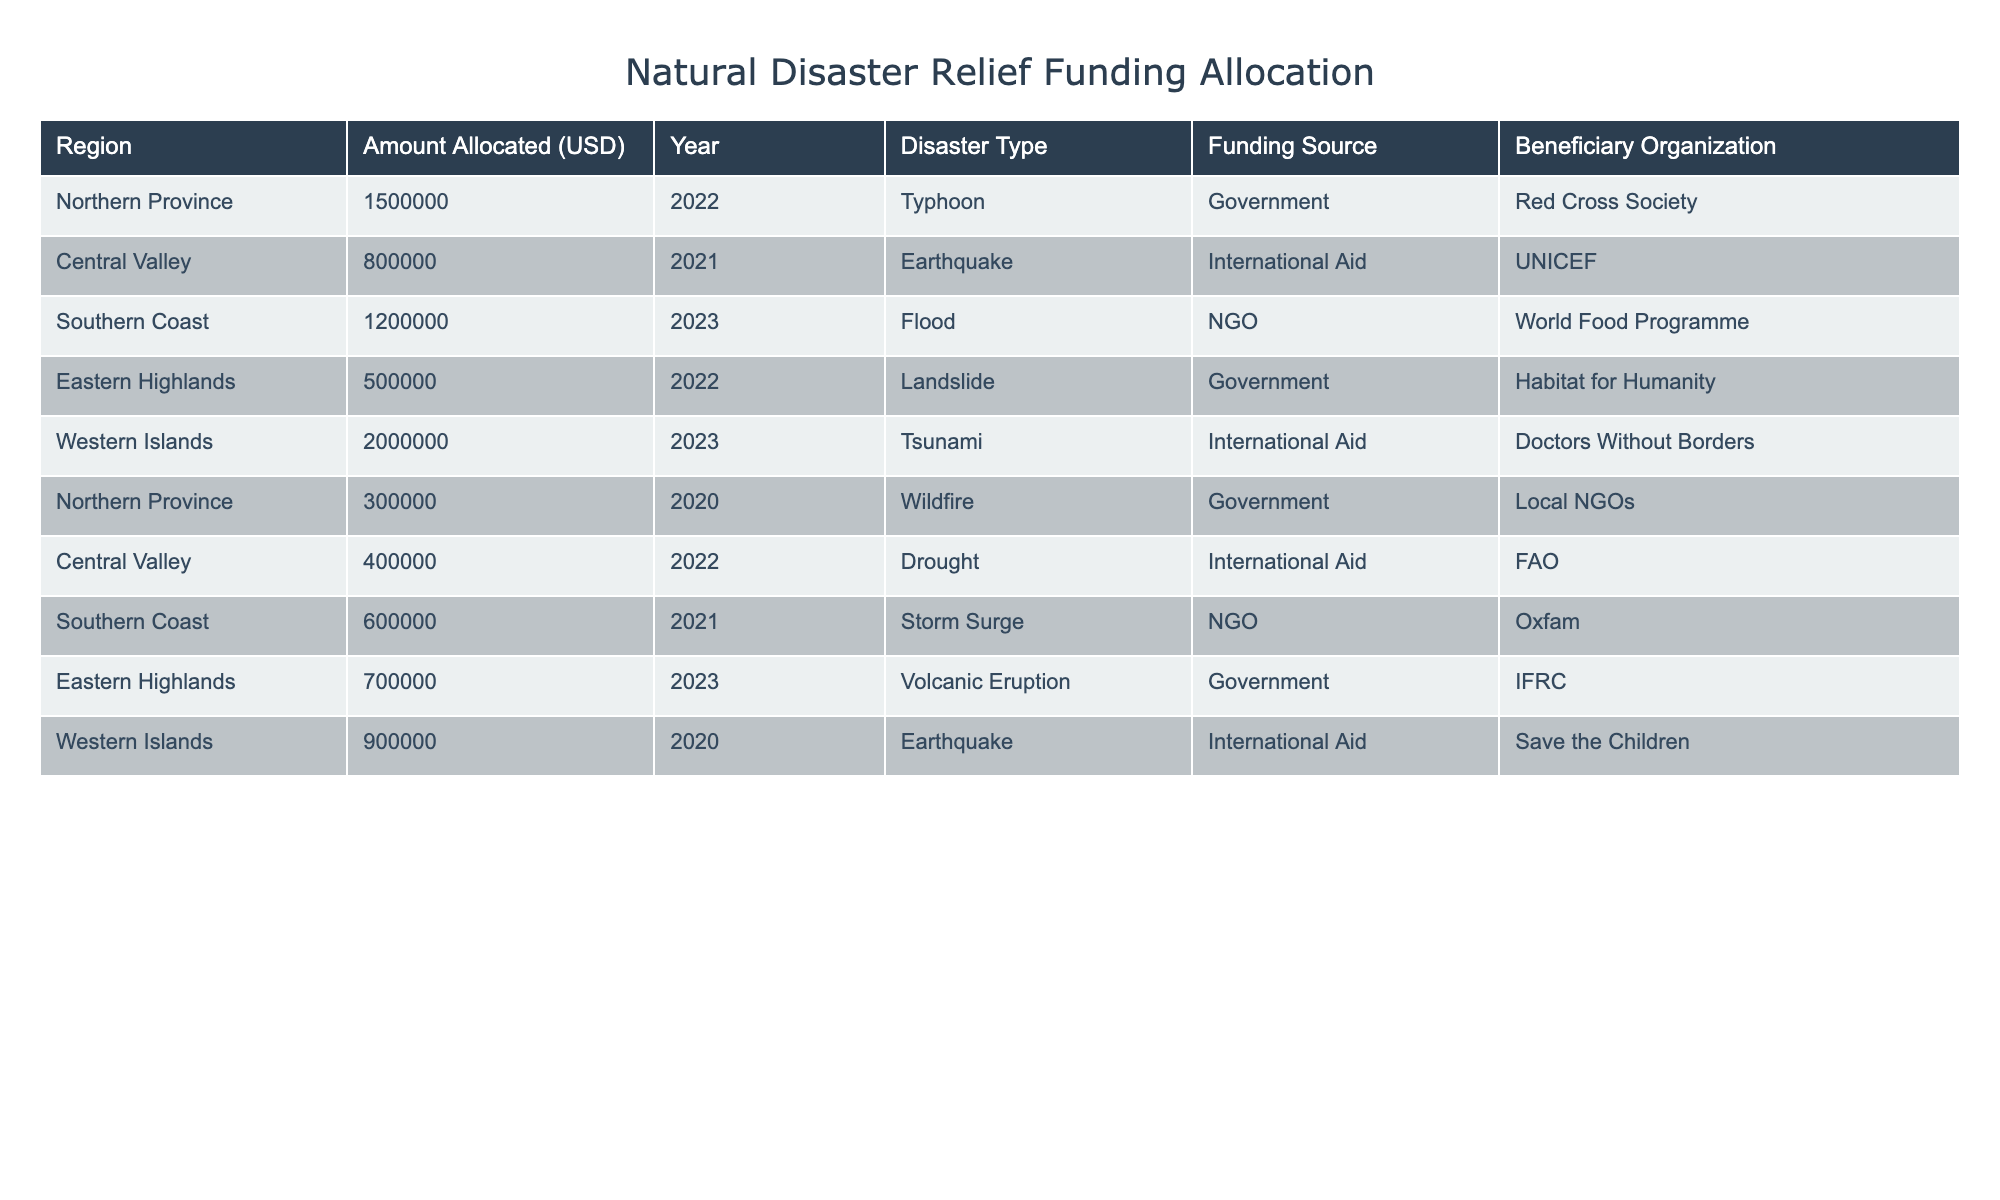What is the total amount allocated for disaster relief funding in the Northern Province? The Northern Province has two entries for disaster relief funding: $1,500,000 in 2022 for a typhoon and $300,000 in 2020 for a wildfire. Adding these amounts together gives $1,500,000 + $300,000 = $1,800,000.
Answer: $1,800,000 Which region received the highest allocation for disaster relief funding in 2023? In 2023, the Southern Coast received $1,200,000 for a flood, and the Western Islands received $2,000,000 for a tsunami. Comparing these figures, $2,000,000 is the highest amount.
Answer: Western Islands Was the funding source for the 2022 landslide in the Eastern Highlands from the government or an international organization? The funding source for the 2022 landslide in Eastern Highlands is listed as "Government," indicating that it is not from an international organization.
Answer: Government What is the average amount allocated for all regions in 2021? There are two entries for 2021: $800,000 for an earthquake in Central Valley and $600,000 for a storm surge in Southern Coast. The total amount is $800,000 + $600,000 = $1,400,000, and dividing this by the number of entries (2) gives the average of $1,400,000 / 2 = $700,000.
Answer: $700,000 Which organization received funds for the earthquake in the Western Islands? The earthquake in the Western Islands occurred in 2020, and the beneficiary organization for this funding is "Save the Children," according to the table.
Answer: Save the Children Did any region receive disaster relief funding from both government and international aid sources in the same year? A comparison of the table shows that the Northern Province received funding from the government in 2022 and had another entry in 2020 also from the government. No region received funding from both sources in the same year according to the provided data.
Answer: No How much total funding was allocated to the Southern Coast for disaster relief over the years listed? The Southern Coast has two funding entries: $1,200,000 for a flood in 2023 and $600,000 for a storm surge in 2021. The total is $1,200,000 + $600,000 = $1,800,000.
Answer: $1,800,000 What proportion of the total funding allocated for the year 2022 was sourced from international aid? In 2022, $1,500,000 was allocated in the Northern Province (government), $400,000 in Central Valley (international aid), and $500,000 in Eastern Highlands (government), totaling $1,500,000 + $400,000 + $500,000 = $2,400,000. The international aid portion is $400,000, giving a proportion of $400,000 / $2,400,000 = 0.1667, or about 16.67%.
Answer: 16.67% Which region suffered from more than one type of disaster according to the data? The data shows that each region has a unique type of disaster listed, without any region having multiple disaster types recorded. Thus, no region suffered from more than one type of disaster according to the provided data.
Answer: No What was the sum of disaster relief funding allocated specifically for drought and wildfire incidents? The drought incident in the Central Valley had $400,000 allocated, and the wildfire in the Northern Province had $300,000 allocated. Adding these amounts gives $400,000 + $300,000 = $700,000.
Answer: $700,000 